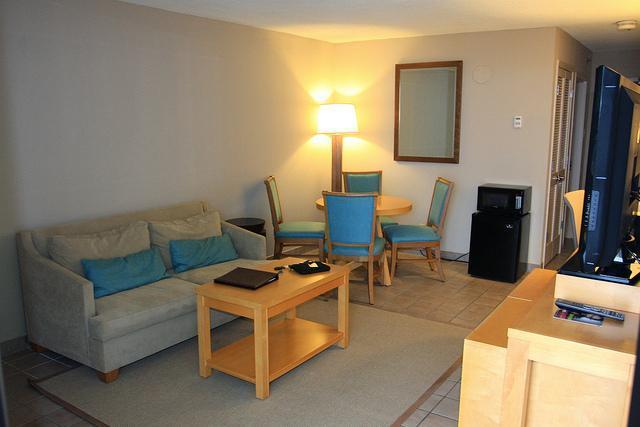How many chairs are in this picture?
Give a very brief answer. 4. How many lights are on?
Give a very brief answer. 1. How many candles are on the table?
Give a very brief answer. 0. How many chairs are seen?
Give a very brief answer. 4. How many chairs are there?
Give a very brief answer. 3. How many couches can you see?
Give a very brief answer. 1. 